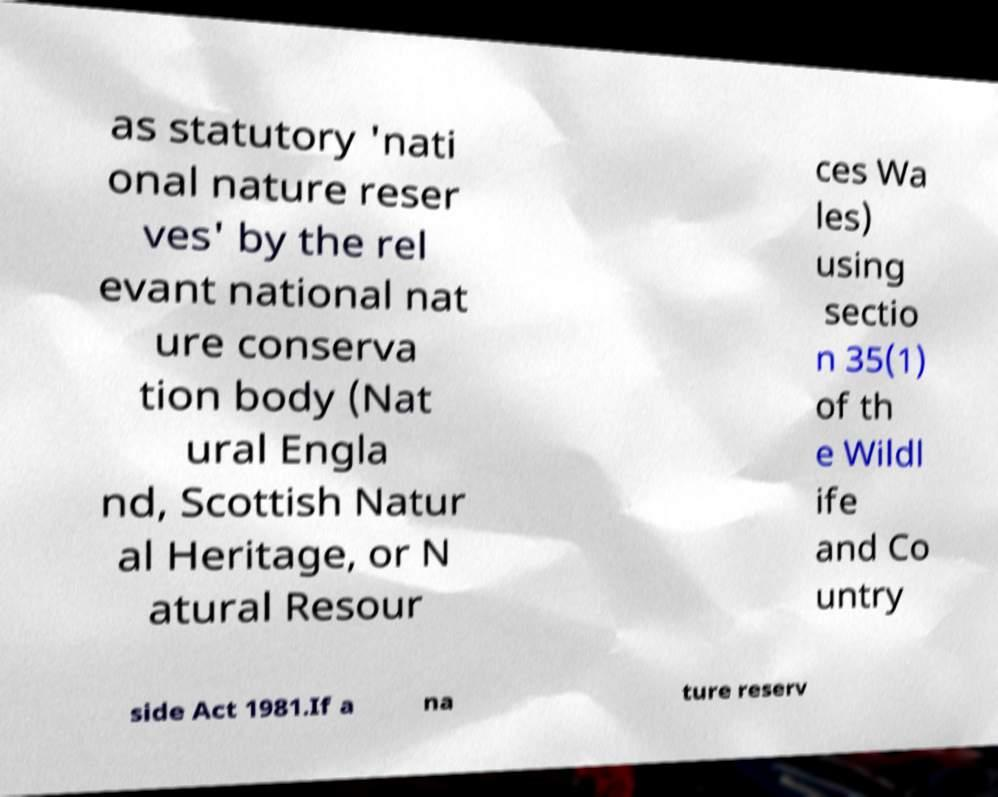I need the written content from this picture converted into text. Can you do that? as statutory 'nati onal nature reser ves' by the rel evant national nat ure conserva tion body (Nat ural Engla nd, Scottish Natur al Heritage, or N atural Resour ces Wa les) using sectio n 35(1) of th e Wildl ife and Co untry side Act 1981.If a na ture reserv 